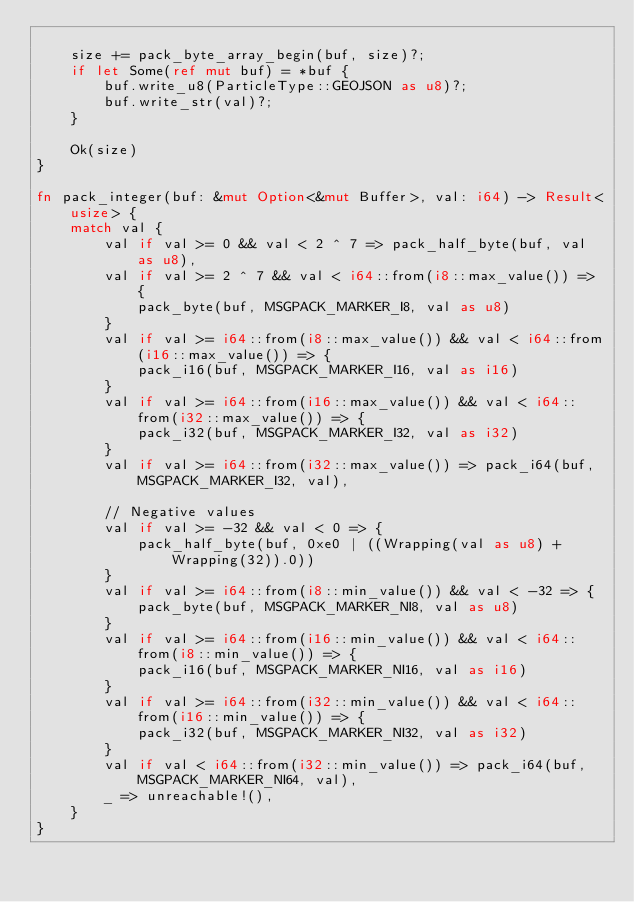<code> <loc_0><loc_0><loc_500><loc_500><_Rust_>
    size += pack_byte_array_begin(buf, size)?;
    if let Some(ref mut buf) = *buf {
        buf.write_u8(ParticleType::GEOJSON as u8)?;
        buf.write_str(val)?;
    }

    Ok(size)
}

fn pack_integer(buf: &mut Option<&mut Buffer>, val: i64) -> Result<usize> {
    match val {
        val if val >= 0 && val < 2 ^ 7 => pack_half_byte(buf, val as u8),
        val if val >= 2 ^ 7 && val < i64::from(i8::max_value()) => {
            pack_byte(buf, MSGPACK_MARKER_I8, val as u8)
        }
        val if val >= i64::from(i8::max_value()) && val < i64::from(i16::max_value()) => {
            pack_i16(buf, MSGPACK_MARKER_I16, val as i16)
        }
        val if val >= i64::from(i16::max_value()) && val < i64::from(i32::max_value()) => {
            pack_i32(buf, MSGPACK_MARKER_I32, val as i32)
        }
        val if val >= i64::from(i32::max_value()) => pack_i64(buf, MSGPACK_MARKER_I32, val),

        // Negative values
        val if val >= -32 && val < 0 => {
            pack_half_byte(buf, 0xe0 | ((Wrapping(val as u8) + Wrapping(32)).0))
        }
        val if val >= i64::from(i8::min_value()) && val < -32 => {
            pack_byte(buf, MSGPACK_MARKER_NI8, val as u8)
        }
        val if val >= i64::from(i16::min_value()) && val < i64::from(i8::min_value()) => {
            pack_i16(buf, MSGPACK_MARKER_NI16, val as i16)
        }
        val if val >= i64::from(i32::min_value()) && val < i64::from(i16::min_value()) => {
            pack_i32(buf, MSGPACK_MARKER_NI32, val as i32)
        }
        val if val < i64::from(i32::min_value()) => pack_i64(buf, MSGPACK_MARKER_NI64, val),
        _ => unreachable!(),
    }
}
</code> 